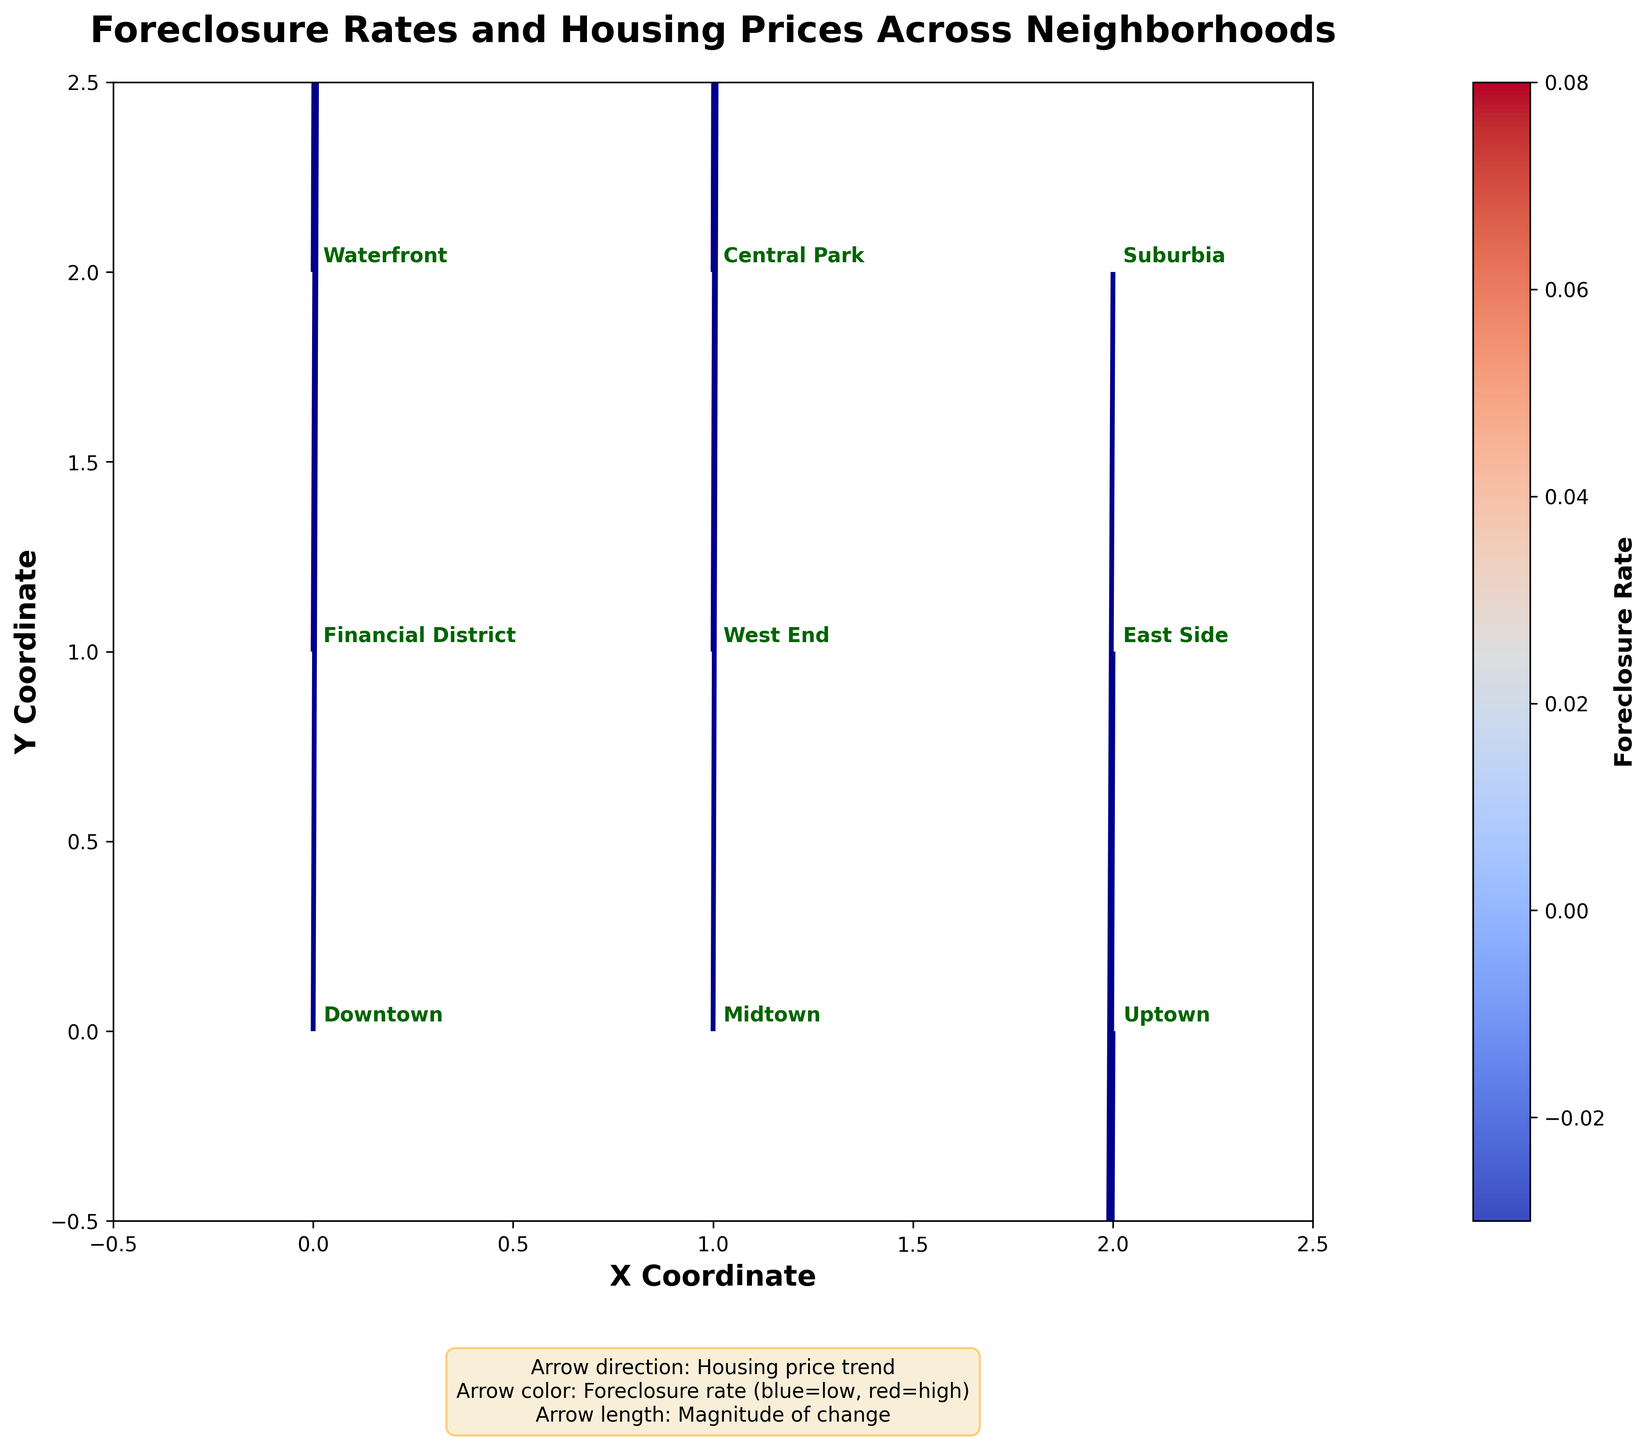What is the title of the plot? The title is displayed prominently at the top of the chart, in a larger font size, and usually bold to differentiate it from other text. In this plot, the title is "Foreclosure Rates and Housing Prices Across Neighborhoods".
Answer: Foreclosure Rates and Housing Prices Across Neighborhoods How many neighborhoods are represented in this plot? Each neighborhood is labeled with its name near its corresponding arrow on the plot. There are names around nine different points, indicating the number of neighborhoods.
Answer: 9 Which neighborhood shows the highest positive trend in housing prices? By looking at the direction of the arrows, the longest vector pointing upward indicates the highest positive trend in housing prices. The Financial District shows the most significant upward vector.
Answer: Financial District How does the foreclosure rate in Uptown compare to Downtown? The arrows' colors indicate the foreclosure rates, with blue representing low rates and red representing high rates. Uptown has an arrow pointing downwards (suggesting a negative trend in housing prices) and Downtown has a higher foreclosure rate (indicated by a less positive trend). This comparison shows Uptown has a lower foreclosure rate than Downtown.
Answer: Uptown has a lower foreclosure rate than Downtown Which neighborhoods have a negative trend in housing prices? Negative trends in housing prices are shown by vectors pointing downwards. By inspecting the direction of vectors, neighborhoods with negative arrows are Uptown, East Side, and Suburbia.
Answer: Uptown, East Side, Suburbia In which neighborhood is the increase in housing prices the smallest despite a positive trend? Among the neighborhoods with upward-pointing vectors (positive trends), the shortest vector represents the smallest increase in housing prices. Central Park shows the smallest upward trend.
Answer: Central Park Which neighborhood has the highest foreclosure rate? The color of the arrow represents the foreclosure rate, with more intense colors indicating higher rates. Among the arrows, the Financial District has the most vibrant color, indicating the highest foreclosure rate.
Answer: Financial District Are there any neighborhoods where both the foreclosure rate and housing prices are declining? A declining housing price trend is indicated by downward-pointing vectors. In neighborhoods like Uptown, East Side, and Suburbia, the vectors point downward, which means housing prices are falling; checking the colors, Suburbia has a higher foreclosure rate with its redder arrow.
Answer: Suburbia What general trend can be observed in the Financial District? The vector's direction and color both need to be considered. The arrow points upward with the steepest slope and is darkest, indicating a significant positive trend in housing prices and a high foreclosure rate.
Answer: High foreclosure rate with a strong increase in housing prices 